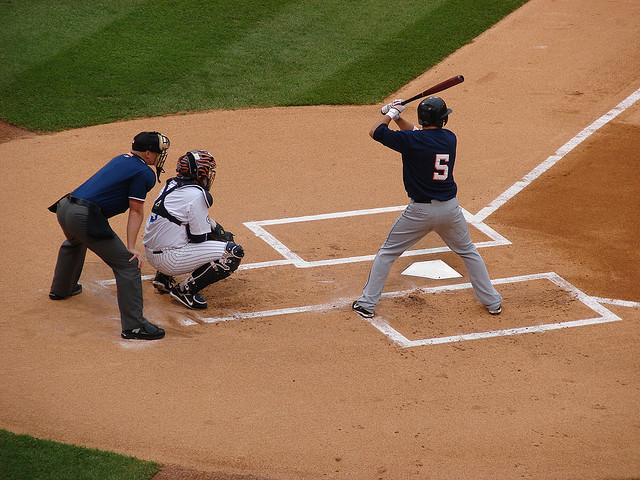Rawlings are the helmets used by whom?

Choices:
A) bbl
B) mlb
C) ttb
D) bsl mlb 